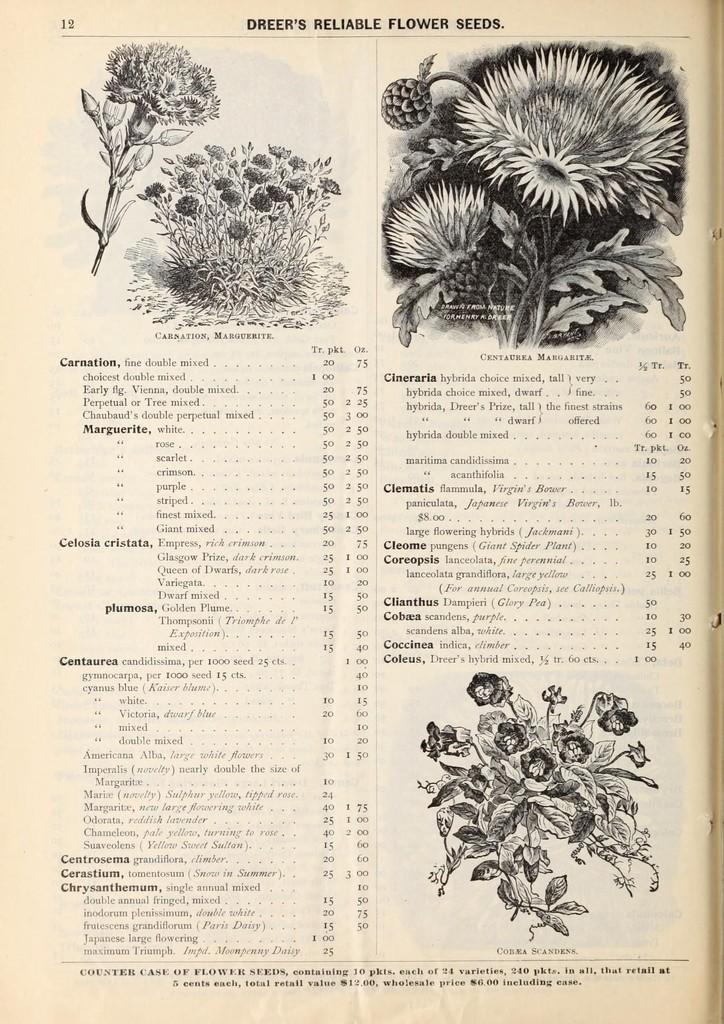What is depicted on the paper in the image? The paper has plants with flowers drawn on it. Are there any words on the paper? Yes, there is text written on the paper. What colors are used on the paper? The paper has a black and cream color scheme. How many friends are depicted on the paper? There are no friends depicted on the paper; it features plants with flowers and text. 